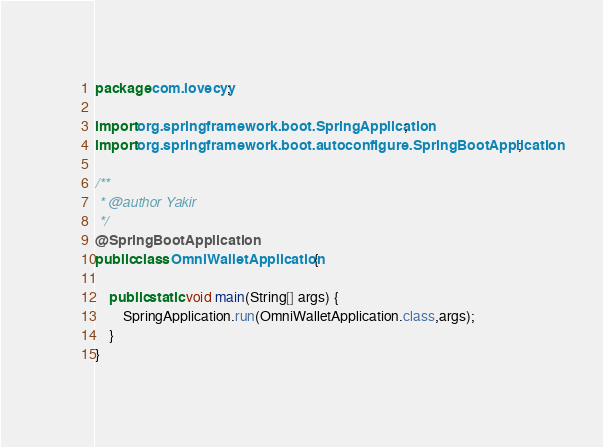<code> <loc_0><loc_0><loc_500><loc_500><_Java_>package com.lovecyy;

import org.springframework.boot.SpringApplication;
import org.springframework.boot.autoconfigure.SpringBootApplication;

/**
 * @author Yakir
 */
@SpringBootApplication
public class OmniWalletApplication {

    public static void main(String[] args) {
        SpringApplication.run(OmniWalletApplication.class,args);
    }
}
</code> 